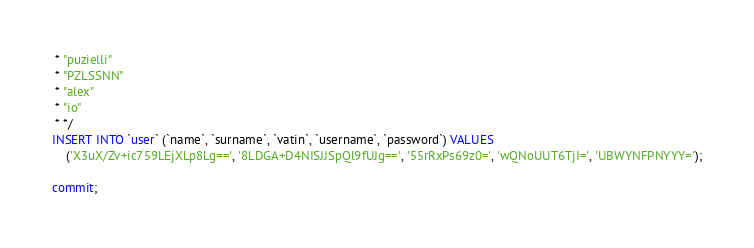Convert code to text. <code><loc_0><loc_0><loc_500><loc_500><_SQL_> * "puzielli"
 * "PZLSSNN"
 * "alex"
 * "io"
 * */
INSERT INTO `user` (`name`, `surname`, `vatin`, `username`, `password`) VALUES
	('X3uX/Zv+ic759LEjXLp8Lg==', '8LDGA+D4NISJJSpQl9fUJg==', '55rRxPs69z0=', 'wQNoUUT6TjI=', 'UBWYNFPNYYY=');

commit;
</code> 